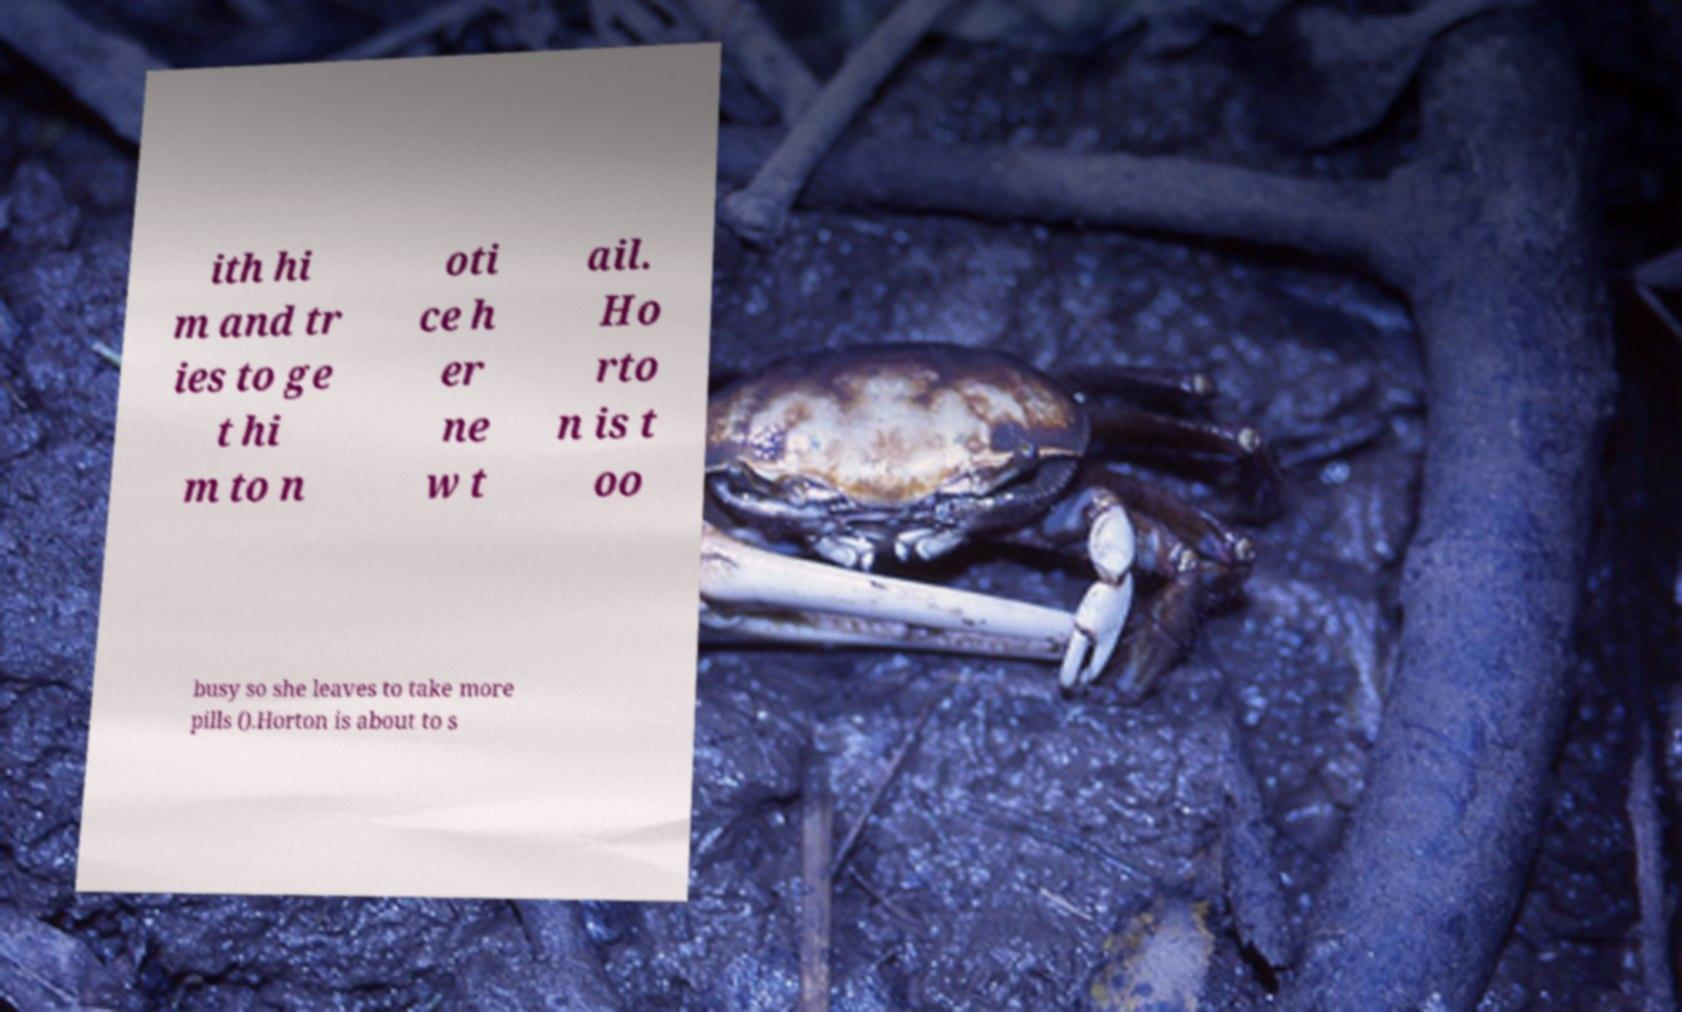Please identify and transcribe the text found in this image. ith hi m and tr ies to ge t hi m to n oti ce h er ne w t ail. Ho rto n is t oo busy so she leaves to take more pills ().Horton is about to s 